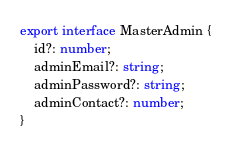Convert code to text. <code><loc_0><loc_0><loc_500><loc_500><_TypeScript_>export interface MasterAdmin {
    id?: number;
    adminEmail?: string;
    adminPassword?: string;
    adminContact?: number;
}</code> 